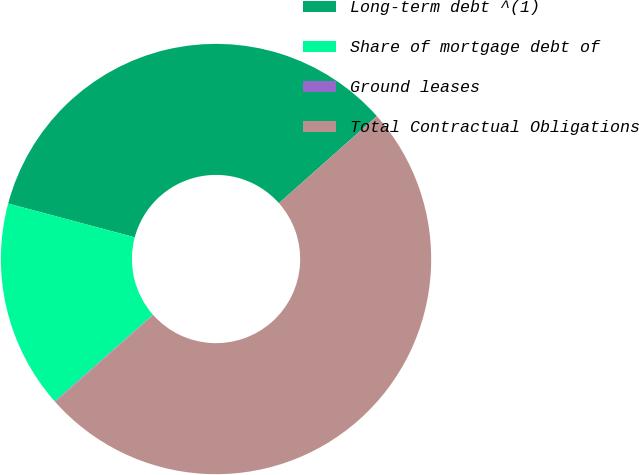<chart> <loc_0><loc_0><loc_500><loc_500><pie_chart><fcel>Long-term debt ^(1)<fcel>Share of mortgage debt of<fcel>Ground leases<fcel>Total Contractual Obligations<nl><fcel>34.29%<fcel>15.66%<fcel>0.05%<fcel>50.0%<nl></chart> 